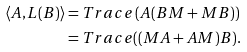<formula> <loc_0><loc_0><loc_500><loc_500>\langle A , L ( B ) \rangle & = { T r a c e } \left ( A ( B M + M B ) \right ) \\ & = { T r a c e } ( ( M A + A M ) B ) .</formula> 